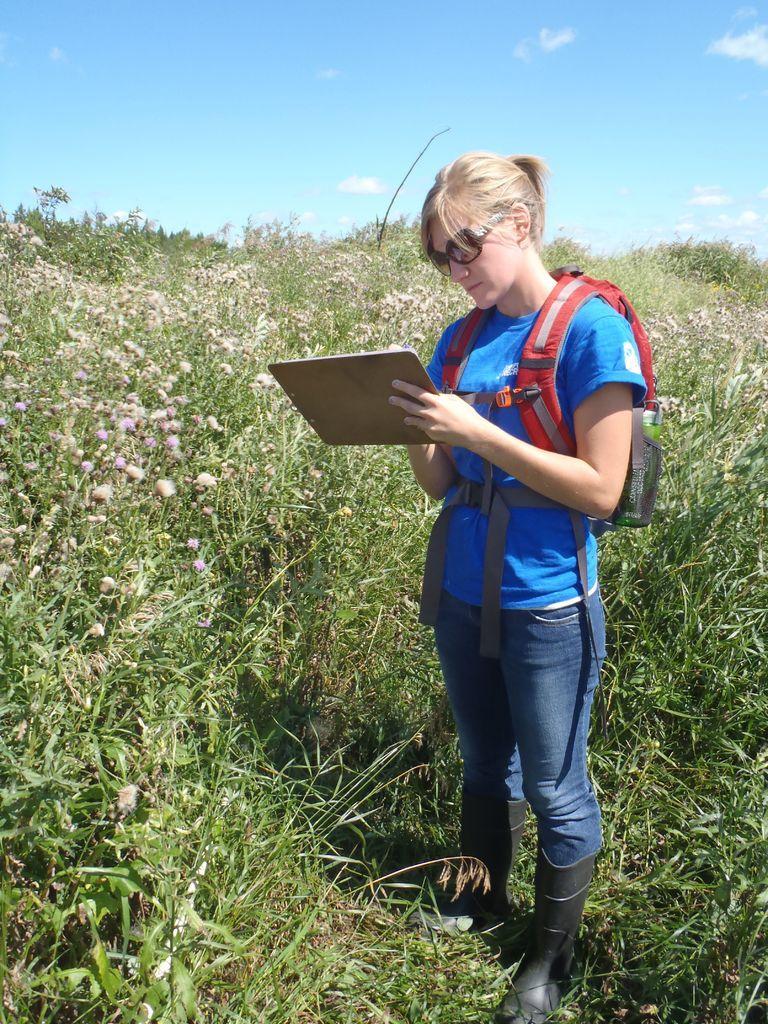Describe this image in one or two sentences. This woman is holding a pad, worn bag, goggles and looking at this pad. Background we can see planets and sky. These are clouds. 